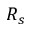<formula> <loc_0><loc_0><loc_500><loc_500>R _ { s }</formula> 